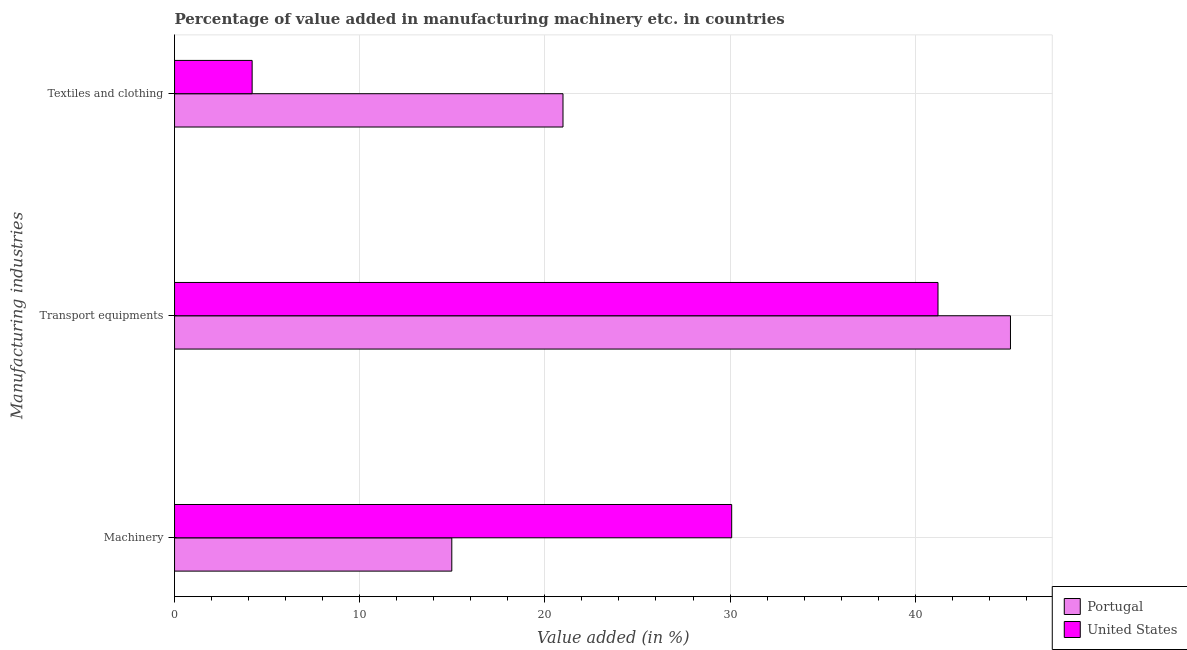Are the number of bars per tick equal to the number of legend labels?
Your answer should be very brief. Yes. Are the number of bars on each tick of the Y-axis equal?
Give a very brief answer. Yes. How many bars are there on the 1st tick from the top?
Your answer should be compact. 2. What is the label of the 1st group of bars from the top?
Your answer should be compact. Textiles and clothing. What is the value added in manufacturing transport equipments in Portugal?
Make the answer very short. 45.15. Across all countries, what is the maximum value added in manufacturing transport equipments?
Your answer should be very brief. 45.15. Across all countries, what is the minimum value added in manufacturing transport equipments?
Offer a very short reply. 41.23. In which country was the value added in manufacturing transport equipments maximum?
Offer a terse response. Portugal. What is the total value added in manufacturing transport equipments in the graph?
Provide a short and direct response. 86.38. What is the difference between the value added in manufacturing transport equipments in United States and that in Portugal?
Provide a succinct answer. -3.91. What is the difference between the value added in manufacturing machinery in Portugal and the value added in manufacturing textile and clothing in United States?
Provide a short and direct response. 10.78. What is the average value added in manufacturing transport equipments per country?
Give a very brief answer. 43.19. What is the difference between the value added in manufacturing textile and clothing and value added in manufacturing machinery in United States?
Offer a terse response. -25.9. What is the ratio of the value added in manufacturing transport equipments in Portugal to that in United States?
Offer a very short reply. 1.09. Is the value added in manufacturing machinery in Portugal less than that in United States?
Offer a terse response. Yes. What is the difference between the highest and the second highest value added in manufacturing textile and clothing?
Make the answer very short. 16.79. What is the difference between the highest and the lowest value added in manufacturing machinery?
Make the answer very short. 15.12. In how many countries, is the value added in manufacturing textile and clothing greater than the average value added in manufacturing textile and clothing taken over all countries?
Provide a succinct answer. 1. Is the sum of the value added in manufacturing textile and clothing in United States and Portugal greater than the maximum value added in manufacturing machinery across all countries?
Give a very brief answer. No. What does the 1st bar from the top in Textiles and clothing represents?
Give a very brief answer. United States. Is it the case that in every country, the sum of the value added in manufacturing machinery and value added in manufacturing transport equipments is greater than the value added in manufacturing textile and clothing?
Your response must be concise. Yes. How many bars are there?
Ensure brevity in your answer.  6. Are all the bars in the graph horizontal?
Offer a very short reply. Yes. How many countries are there in the graph?
Provide a succinct answer. 2. Does the graph contain grids?
Provide a succinct answer. Yes. How are the legend labels stacked?
Your answer should be very brief. Vertical. What is the title of the graph?
Keep it short and to the point. Percentage of value added in manufacturing machinery etc. in countries. What is the label or title of the X-axis?
Offer a terse response. Value added (in %). What is the label or title of the Y-axis?
Your response must be concise. Manufacturing industries. What is the Value added (in %) of Portugal in Machinery?
Give a very brief answer. 14.97. What is the Value added (in %) of United States in Machinery?
Give a very brief answer. 30.09. What is the Value added (in %) of Portugal in Transport equipments?
Give a very brief answer. 45.15. What is the Value added (in %) in United States in Transport equipments?
Offer a terse response. 41.23. What is the Value added (in %) in Portugal in Textiles and clothing?
Your response must be concise. 20.98. What is the Value added (in %) of United States in Textiles and clothing?
Make the answer very short. 4.19. Across all Manufacturing industries, what is the maximum Value added (in %) of Portugal?
Provide a succinct answer. 45.15. Across all Manufacturing industries, what is the maximum Value added (in %) in United States?
Offer a terse response. 41.23. Across all Manufacturing industries, what is the minimum Value added (in %) in Portugal?
Offer a terse response. 14.97. Across all Manufacturing industries, what is the minimum Value added (in %) of United States?
Your response must be concise. 4.19. What is the total Value added (in %) in Portugal in the graph?
Your answer should be very brief. 81.1. What is the total Value added (in %) in United States in the graph?
Your answer should be very brief. 75.51. What is the difference between the Value added (in %) of Portugal in Machinery and that in Transport equipments?
Keep it short and to the point. -30.17. What is the difference between the Value added (in %) in United States in Machinery and that in Transport equipments?
Ensure brevity in your answer.  -11.14. What is the difference between the Value added (in %) of Portugal in Machinery and that in Textiles and clothing?
Offer a very short reply. -6.01. What is the difference between the Value added (in %) in United States in Machinery and that in Textiles and clothing?
Offer a terse response. 25.9. What is the difference between the Value added (in %) in Portugal in Transport equipments and that in Textiles and clothing?
Offer a very short reply. 24.17. What is the difference between the Value added (in %) of United States in Transport equipments and that in Textiles and clothing?
Keep it short and to the point. 37.04. What is the difference between the Value added (in %) in Portugal in Machinery and the Value added (in %) in United States in Transport equipments?
Your answer should be very brief. -26.26. What is the difference between the Value added (in %) in Portugal in Machinery and the Value added (in %) in United States in Textiles and clothing?
Ensure brevity in your answer.  10.78. What is the difference between the Value added (in %) of Portugal in Transport equipments and the Value added (in %) of United States in Textiles and clothing?
Make the answer very short. 40.96. What is the average Value added (in %) of Portugal per Manufacturing industries?
Offer a terse response. 27.03. What is the average Value added (in %) in United States per Manufacturing industries?
Make the answer very short. 25.17. What is the difference between the Value added (in %) of Portugal and Value added (in %) of United States in Machinery?
Make the answer very short. -15.12. What is the difference between the Value added (in %) in Portugal and Value added (in %) in United States in Transport equipments?
Give a very brief answer. 3.91. What is the difference between the Value added (in %) of Portugal and Value added (in %) of United States in Textiles and clothing?
Keep it short and to the point. 16.79. What is the ratio of the Value added (in %) of Portugal in Machinery to that in Transport equipments?
Ensure brevity in your answer.  0.33. What is the ratio of the Value added (in %) of United States in Machinery to that in Transport equipments?
Your response must be concise. 0.73. What is the ratio of the Value added (in %) of Portugal in Machinery to that in Textiles and clothing?
Your response must be concise. 0.71. What is the ratio of the Value added (in %) in United States in Machinery to that in Textiles and clothing?
Provide a short and direct response. 7.18. What is the ratio of the Value added (in %) in Portugal in Transport equipments to that in Textiles and clothing?
Your response must be concise. 2.15. What is the ratio of the Value added (in %) of United States in Transport equipments to that in Textiles and clothing?
Your answer should be very brief. 9.84. What is the difference between the highest and the second highest Value added (in %) in Portugal?
Provide a succinct answer. 24.17. What is the difference between the highest and the second highest Value added (in %) of United States?
Offer a very short reply. 11.14. What is the difference between the highest and the lowest Value added (in %) in Portugal?
Your answer should be very brief. 30.17. What is the difference between the highest and the lowest Value added (in %) in United States?
Your answer should be compact. 37.04. 